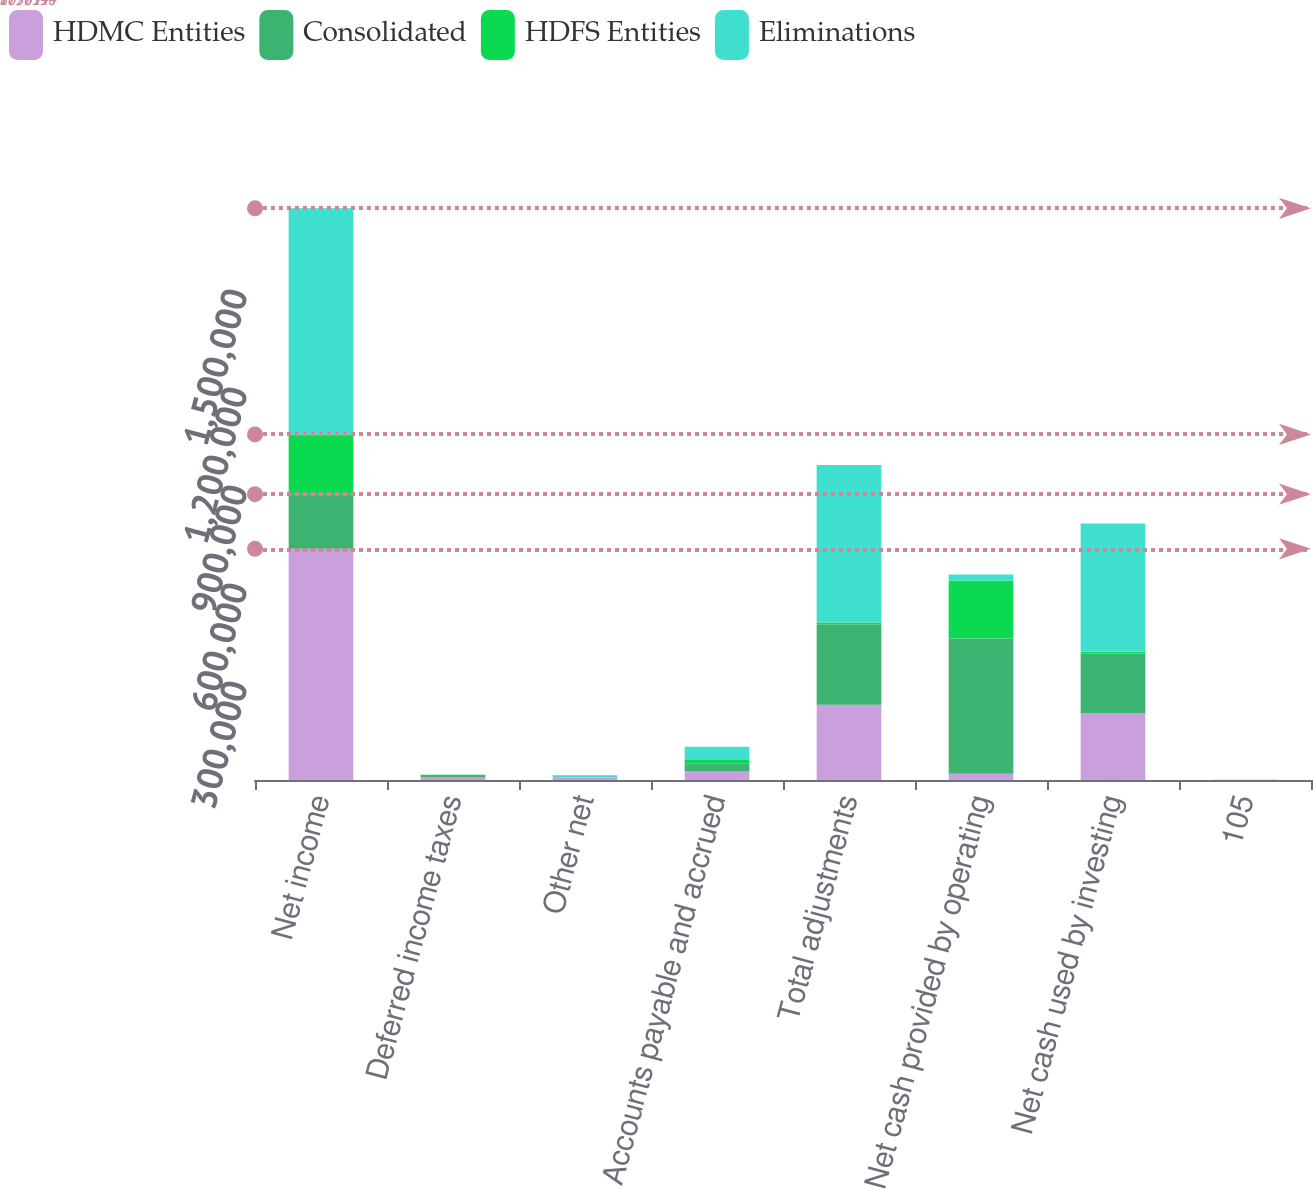Convert chart. <chart><loc_0><loc_0><loc_500><loc_500><stacked_bar_chart><ecel><fcel>Net income<fcel>Deferred income taxes<fcel>Other net<fcel>Accounts payable and accrued<fcel>Total adjustments<fcel>Net cash provided by operating<fcel>Net cash used by investing<fcel>105<nl><fcel>HDMC Entities<fcel>707614<fcel>7772<fcel>7041<fcel>26005<fcel>230410<fcel>18911<fcel>204891<fcel>105<nl><fcel>Consolidated<fcel>167445<fcel>7705<fcel>239<fcel>25027<fcel>246443<fcel>413888<fcel>182413<fcel>105<nl><fcel>HDFS Entities<fcel>182895<fcel>232<fcel>105<fcel>12795<fcel>5322<fcel>177573<fcel>5427<fcel>105<nl><fcel>Eliminations<fcel>692164<fcel>165<fcel>6907<fcel>38237<fcel>482175<fcel>18911<fcel>392731<fcel>105<nl></chart> 